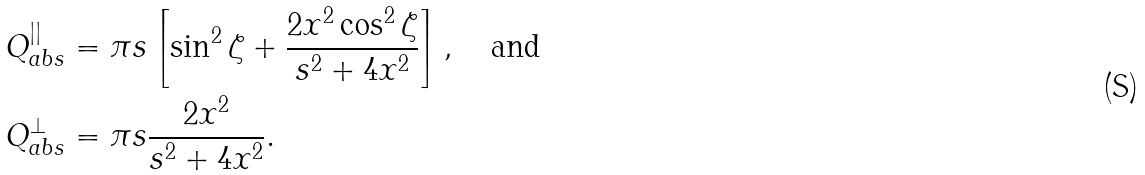<formula> <loc_0><loc_0><loc_500><loc_500>Q _ { a b s } ^ { | | } & = \pi s \left [ \sin ^ { 2 } \zeta + \frac { 2 x ^ { 2 } \cos ^ { 2 } \zeta } { s ^ { 2 } + 4 x ^ { 2 } } \right ] , \quad \text {and} \\ Q _ { a b s } ^ { \perp } & = \pi s \frac { 2 x ^ { 2 } } { s ^ { 2 } + 4 x ^ { 2 } } .</formula> 